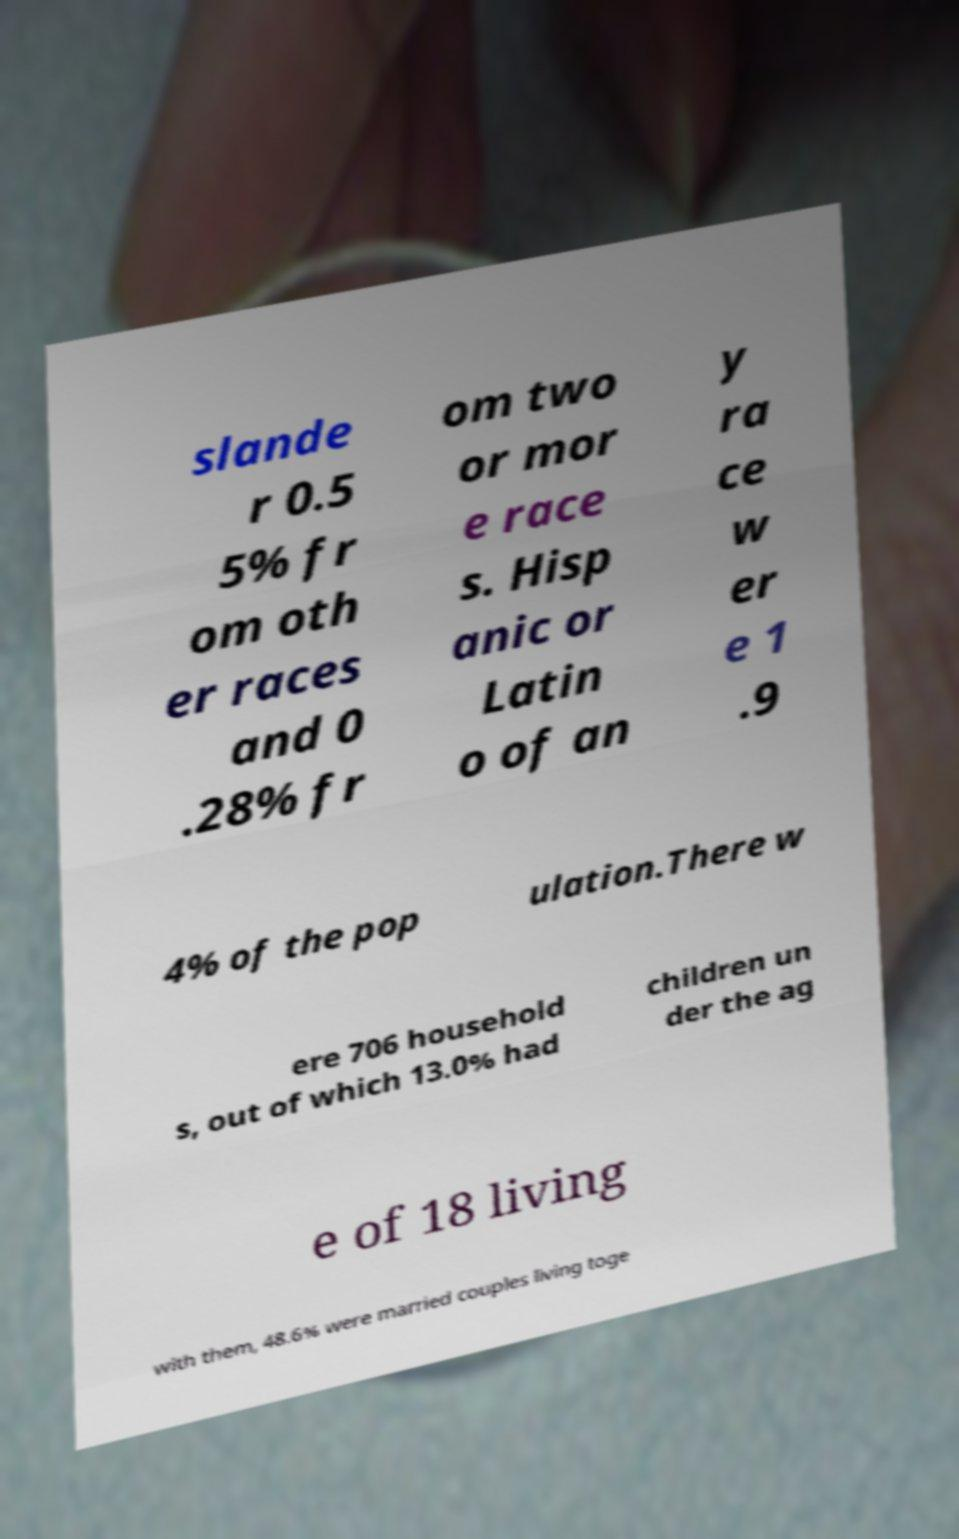Could you assist in decoding the text presented in this image and type it out clearly? slande r 0.5 5% fr om oth er races and 0 .28% fr om two or mor e race s. Hisp anic or Latin o of an y ra ce w er e 1 .9 4% of the pop ulation.There w ere 706 household s, out of which 13.0% had children un der the ag e of 18 living with them, 48.6% were married couples living toge 